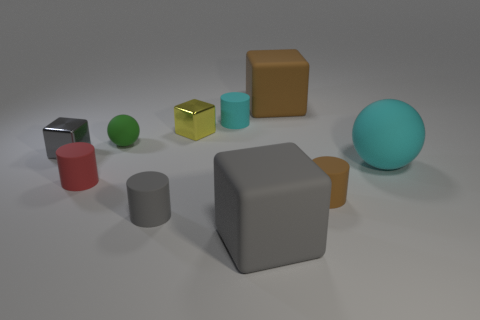Are there any small red cylinders in front of the tiny gray matte object that is on the left side of the small object that is right of the large gray cube?
Keep it short and to the point. No. What number of matte cylinders are there?
Offer a very short reply. 4. What number of things are gray cubes that are on the right side of the small cyan matte object or large rubber cubes that are in front of the small red cylinder?
Ensure brevity in your answer.  1. There is a brown thing on the left side of the brown cylinder; does it have the same size as the yellow metallic cube?
Provide a succinct answer. No. The gray matte object that is the same shape as the large brown matte object is what size?
Your response must be concise. Large. There is a sphere that is the same size as the brown matte cylinder; what material is it?
Ensure brevity in your answer.  Rubber. What is the material of the other big gray object that is the same shape as the gray shiny thing?
Your answer should be compact. Rubber. What number of other objects are there of the same size as the gray cylinder?
Provide a short and direct response. 6. There is a cylinder that is the same color as the big rubber sphere; what size is it?
Your answer should be compact. Small. What number of rubber things have the same color as the large sphere?
Your answer should be very brief. 1. 